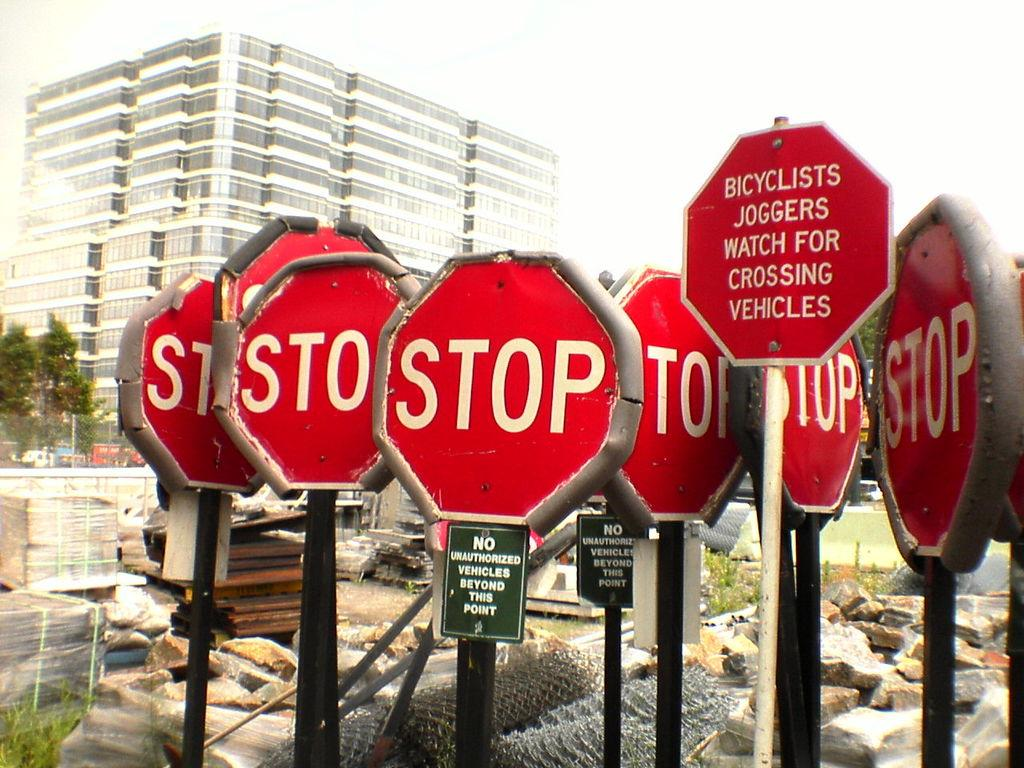<image>
Write a terse but informative summary of the picture. six stop signs and a red octogon warning for Bicycllst and joggers 